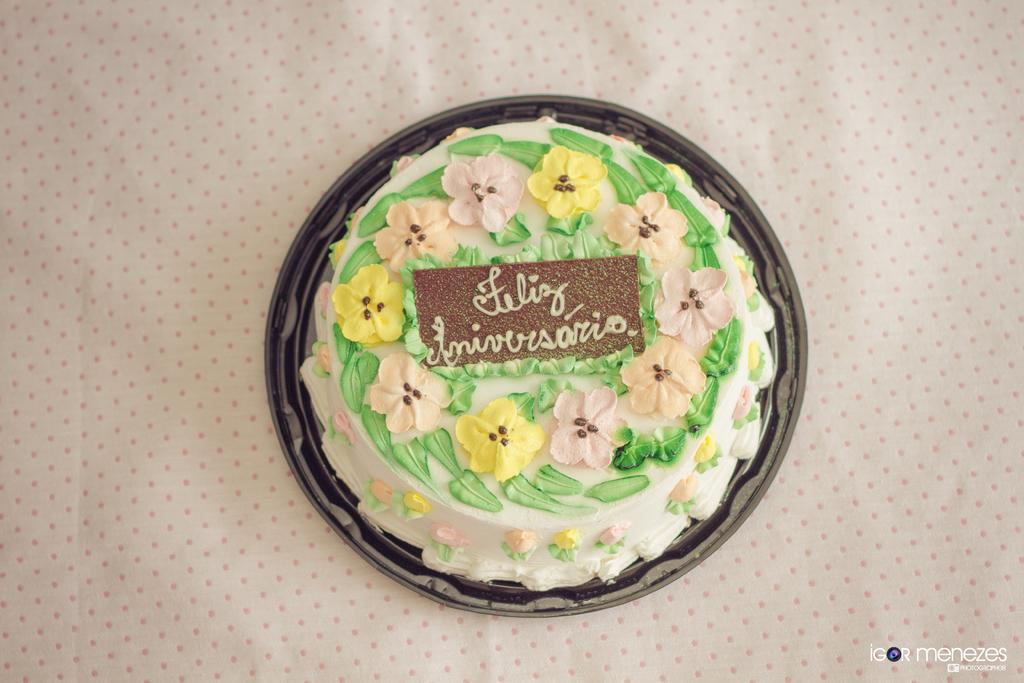What is the main subject in the center of the image? There is a cake in the center of the image. What decorations are on the cake? The cake has flowers on it. What is the cake placed on? The cake is placed on a cloth. Where is the text located in the image? The text is at the bottom towards the right side of the image. What type of station is visible in the image? There is no station present in the image. Can you tell me how many people are driving in the image? There is no driving or vehicles present in the image. 